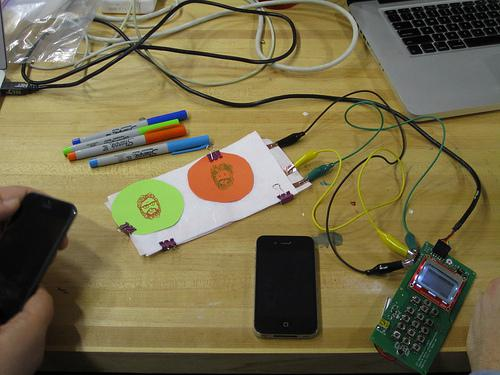Question: why would you need markers?
Choices:
A. To paint or write.
B. To label.
C. To underline.
D. To highlight.
Answer with the letter. Answer: A Question: why is the person holding the phone?
Choices:
A. Programming.
B. Talking.
C. Waiting.
D. Texting.
Answer with the letter. Answer: A Question: what is the person holding?
Choices:
A. A candle.
B. A remote.
C. A book.
D. A phone.
Answer with the letter. Answer: D Question: what color laptop is it?
Choices:
A. White.
B. Grey.
C. Black.
D. Pink.
Answer with the letter. Answer: B 